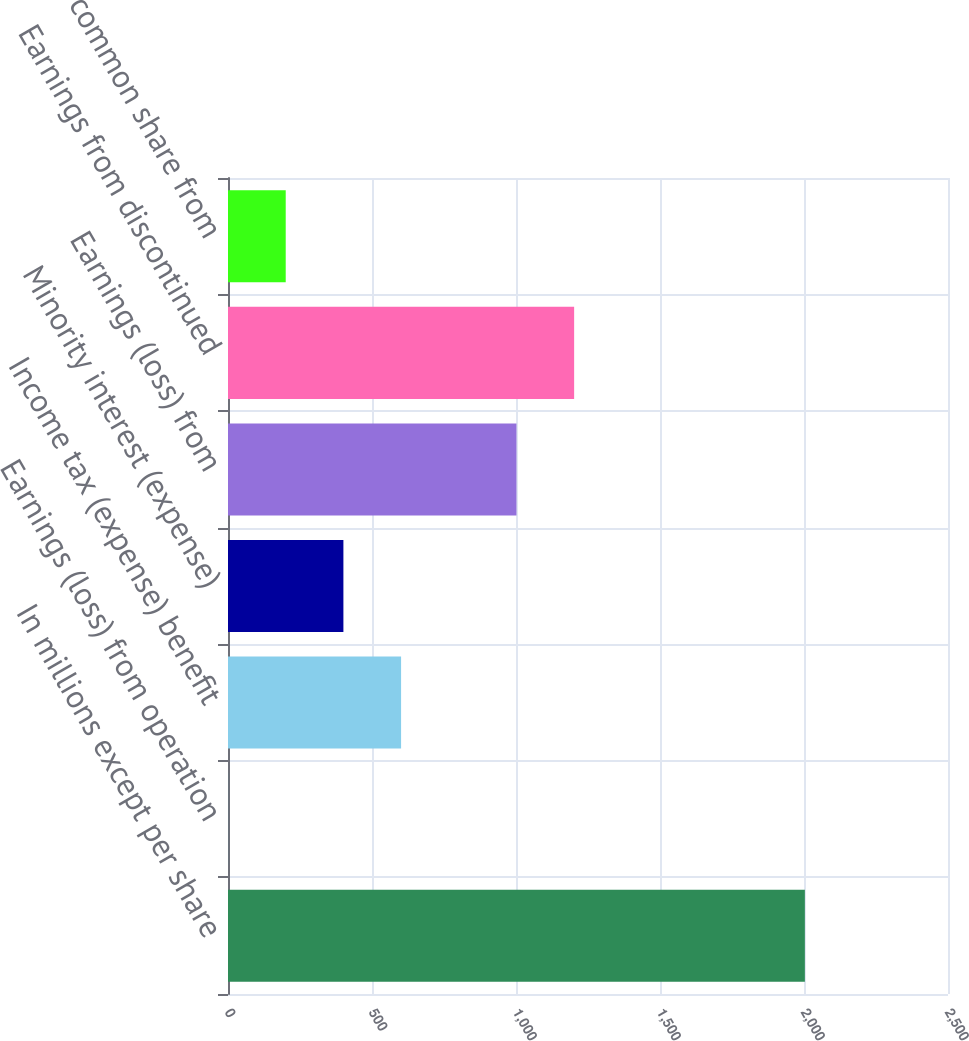<chart> <loc_0><loc_0><loc_500><loc_500><bar_chart><fcel>In millions except per share<fcel>Earnings (loss) from operation<fcel>Income tax (expense) benefit<fcel>Minority interest (expense)<fcel>Earnings (loss) from<fcel>Earnings from discontinued<fcel>Earnings per common share from<nl><fcel>2003<fcel>0.11<fcel>600.98<fcel>400.69<fcel>1001.56<fcel>1201.85<fcel>200.4<nl></chart> 